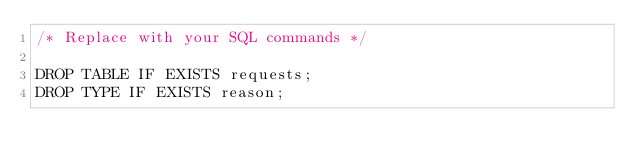<code> <loc_0><loc_0><loc_500><loc_500><_SQL_>/* Replace with your SQL commands */

DROP TABLE IF EXISTS requests;
DROP TYPE IF EXISTS reason;
</code> 